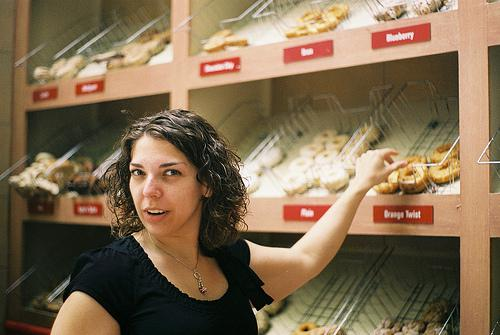Question: what is black?
Choices:
A. The sky.
B. The car.
C. The water.
D. Woman's shirt.
Answer with the letter. Answer: D Question: who is wearing a necklace?
Choices:
A. The woman.
B. The man.
C. The girl.
D. The baby.
Answer with the letter. Answer: A Question: how many people are in the photo?
Choices:
A. Two.
B. Three.
C. One.
D. Four.
Answer with the letter. Answer: C Question: who has brown hair?
Choices:
A. The cow.
B. The dog.
C. The baby.
D. A woman.
Answer with the letter. Answer: D Question: what color are the signs?
Choices:
A. Yellow.
B. Green.
C. Red.
D. Orange.
Answer with the letter. Answer: C 